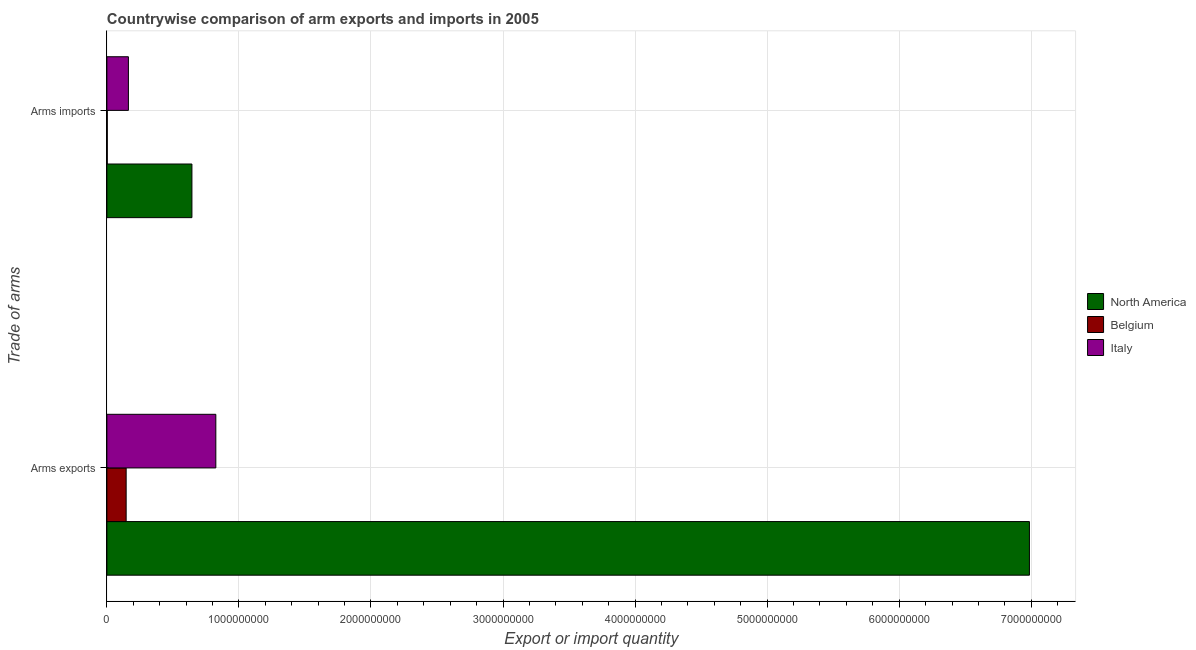How many different coloured bars are there?
Offer a very short reply. 3. Are the number of bars on each tick of the Y-axis equal?
Make the answer very short. Yes. How many bars are there on the 1st tick from the bottom?
Provide a short and direct response. 3. What is the label of the 1st group of bars from the top?
Provide a succinct answer. Arms imports. What is the arms imports in Italy?
Your answer should be very brief. 1.63e+08. Across all countries, what is the maximum arms imports?
Give a very brief answer. 6.44e+08. Across all countries, what is the minimum arms exports?
Your answer should be very brief. 1.46e+08. In which country was the arms exports maximum?
Your response must be concise. North America. What is the total arms exports in the graph?
Offer a terse response. 7.96e+09. What is the difference between the arms exports in Italy and that in North America?
Give a very brief answer. -6.16e+09. What is the difference between the arms exports in North America and the arms imports in Belgium?
Make the answer very short. 6.98e+09. What is the average arms exports per country?
Offer a very short reply. 2.65e+09. What is the difference between the arms exports and arms imports in North America?
Give a very brief answer. 6.34e+09. In how many countries, is the arms exports greater than 5400000000 ?
Your answer should be very brief. 1. What is the ratio of the arms imports in North America to that in Italy?
Offer a terse response. 3.95. Is the arms exports in Italy less than that in Belgium?
Keep it short and to the point. No. In how many countries, is the arms exports greater than the average arms exports taken over all countries?
Offer a very short reply. 1. What does the 3rd bar from the bottom in Arms imports represents?
Ensure brevity in your answer.  Italy. How many bars are there?
Your answer should be compact. 6. Are all the bars in the graph horizontal?
Your response must be concise. Yes. How many countries are there in the graph?
Provide a succinct answer. 3. Are the values on the major ticks of X-axis written in scientific E-notation?
Offer a very short reply. No. Does the graph contain any zero values?
Your answer should be very brief. No. How many legend labels are there?
Your answer should be very brief. 3. What is the title of the graph?
Keep it short and to the point. Countrywise comparison of arm exports and imports in 2005. Does "Small states" appear as one of the legend labels in the graph?
Ensure brevity in your answer.  No. What is the label or title of the X-axis?
Give a very brief answer. Export or import quantity. What is the label or title of the Y-axis?
Provide a succinct answer. Trade of arms. What is the Export or import quantity in North America in Arms exports?
Provide a succinct answer. 6.99e+09. What is the Export or import quantity in Belgium in Arms exports?
Provide a succinct answer. 1.46e+08. What is the Export or import quantity in Italy in Arms exports?
Give a very brief answer. 8.25e+08. What is the Export or import quantity of North America in Arms imports?
Offer a terse response. 6.44e+08. What is the Export or import quantity of Belgium in Arms imports?
Your answer should be very brief. 3.00e+06. What is the Export or import quantity in Italy in Arms imports?
Make the answer very short. 1.63e+08. Across all Trade of arms, what is the maximum Export or import quantity in North America?
Provide a succinct answer. 6.99e+09. Across all Trade of arms, what is the maximum Export or import quantity in Belgium?
Offer a terse response. 1.46e+08. Across all Trade of arms, what is the maximum Export or import quantity of Italy?
Your answer should be compact. 8.25e+08. Across all Trade of arms, what is the minimum Export or import quantity of North America?
Ensure brevity in your answer.  6.44e+08. Across all Trade of arms, what is the minimum Export or import quantity of Belgium?
Offer a very short reply. 3.00e+06. Across all Trade of arms, what is the minimum Export or import quantity in Italy?
Offer a terse response. 1.63e+08. What is the total Export or import quantity of North America in the graph?
Your response must be concise. 7.63e+09. What is the total Export or import quantity of Belgium in the graph?
Offer a terse response. 1.49e+08. What is the total Export or import quantity in Italy in the graph?
Give a very brief answer. 9.88e+08. What is the difference between the Export or import quantity in North America in Arms exports and that in Arms imports?
Give a very brief answer. 6.34e+09. What is the difference between the Export or import quantity in Belgium in Arms exports and that in Arms imports?
Your answer should be very brief. 1.43e+08. What is the difference between the Export or import quantity of Italy in Arms exports and that in Arms imports?
Ensure brevity in your answer.  6.62e+08. What is the difference between the Export or import quantity in North America in Arms exports and the Export or import quantity in Belgium in Arms imports?
Ensure brevity in your answer.  6.98e+09. What is the difference between the Export or import quantity in North America in Arms exports and the Export or import quantity in Italy in Arms imports?
Your answer should be compact. 6.82e+09. What is the difference between the Export or import quantity in Belgium in Arms exports and the Export or import quantity in Italy in Arms imports?
Ensure brevity in your answer.  -1.70e+07. What is the average Export or import quantity of North America per Trade of arms?
Offer a very short reply. 3.82e+09. What is the average Export or import quantity in Belgium per Trade of arms?
Provide a short and direct response. 7.45e+07. What is the average Export or import quantity of Italy per Trade of arms?
Offer a very short reply. 4.94e+08. What is the difference between the Export or import quantity of North America and Export or import quantity of Belgium in Arms exports?
Offer a very short reply. 6.84e+09. What is the difference between the Export or import quantity of North America and Export or import quantity of Italy in Arms exports?
Your answer should be very brief. 6.16e+09. What is the difference between the Export or import quantity of Belgium and Export or import quantity of Italy in Arms exports?
Your answer should be very brief. -6.79e+08. What is the difference between the Export or import quantity of North America and Export or import quantity of Belgium in Arms imports?
Your response must be concise. 6.41e+08. What is the difference between the Export or import quantity of North America and Export or import quantity of Italy in Arms imports?
Make the answer very short. 4.81e+08. What is the difference between the Export or import quantity in Belgium and Export or import quantity in Italy in Arms imports?
Ensure brevity in your answer.  -1.60e+08. What is the ratio of the Export or import quantity in North America in Arms exports to that in Arms imports?
Offer a terse response. 10.85. What is the ratio of the Export or import quantity of Belgium in Arms exports to that in Arms imports?
Your answer should be very brief. 48.67. What is the ratio of the Export or import quantity of Italy in Arms exports to that in Arms imports?
Your answer should be compact. 5.06. What is the difference between the highest and the second highest Export or import quantity of North America?
Offer a very short reply. 6.34e+09. What is the difference between the highest and the second highest Export or import quantity of Belgium?
Make the answer very short. 1.43e+08. What is the difference between the highest and the second highest Export or import quantity of Italy?
Keep it short and to the point. 6.62e+08. What is the difference between the highest and the lowest Export or import quantity in North America?
Provide a short and direct response. 6.34e+09. What is the difference between the highest and the lowest Export or import quantity of Belgium?
Keep it short and to the point. 1.43e+08. What is the difference between the highest and the lowest Export or import quantity in Italy?
Make the answer very short. 6.62e+08. 